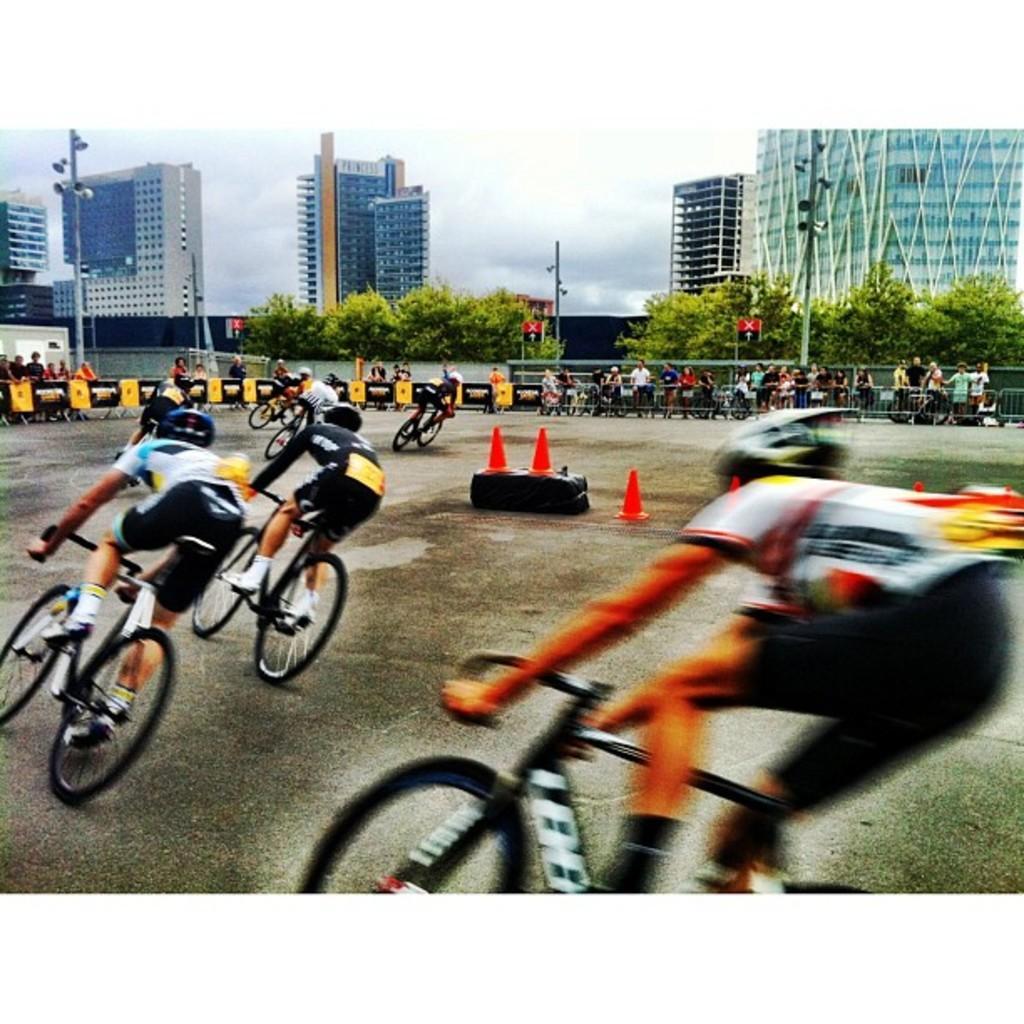Could you give a brief overview of what you see in this image? In this picture in the front there are persons riding bicycle. In the background there are trees, building, poles and there are persons and the sky is cloudy. In the center there are objects which are red and black in colour. 